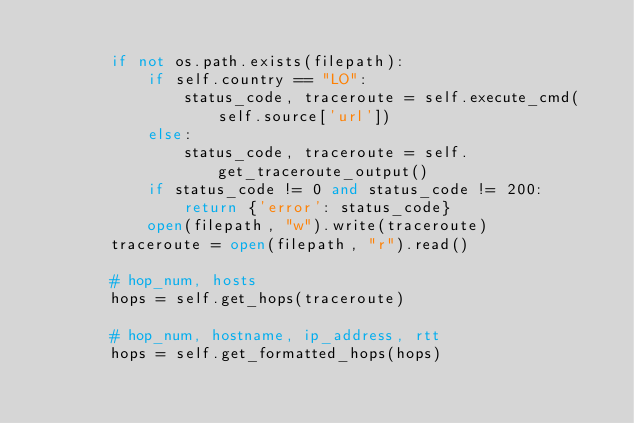<code> <loc_0><loc_0><loc_500><loc_500><_Python_>
        if not os.path.exists(filepath):
            if self.country == "LO":
                status_code, traceroute = self.execute_cmd(self.source['url'])
            else:
                status_code, traceroute = self.get_traceroute_output()
            if status_code != 0 and status_code != 200:
                return {'error': status_code}
            open(filepath, "w").write(traceroute)
        traceroute = open(filepath, "r").read()

        # hop_num, hosts
        hops = self.get_hops(traceroute)

        # hop_num, hostname, ip_address, rtt
        hops = self.get_formatted_hops(hops)
</code> 